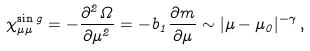<formula> <loc_0><loc_0><loc_500><loc_500>\chi _ { \mu \mu } ^ { \sin g } = - \frac { \partial ^ { 2 } \Omega } { \partial \mu ^ { 2 } } = - b _ { 1 } \frac { \partial m } { \partial \mu } \sim | \mu - \mu _ { 0 } | ^ { - \gamma } \, ,</formula> 